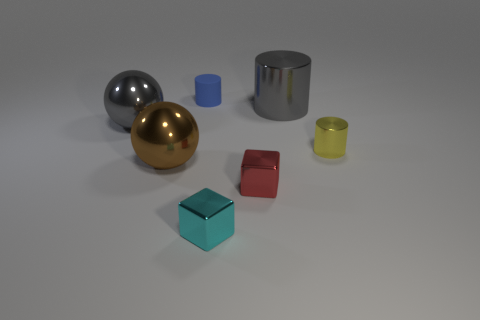Subtract all metal cylinders. How many cylinders are left? 1 Add 1 blue objects. How many objects exist? 8 Subtract all red cubes. How many cubes are left? 1 Subtract 1 blocks. How many blocks are left? 1 Subtract all spheres. How many objects are left? 5 Subtract all brown cylinders. Subtract all blue spheres. How many cylinders are left? 3 Subtract all small metal objects. Subtract all brown shiny things. How many objects are left? 3 Add 3 small blue objects. How many small blue objects are left? 4 Add 7 big brown spheres. How many big brown spheres exist? 8 Subtract 1 blue cylinders. How many objects are left? 6 